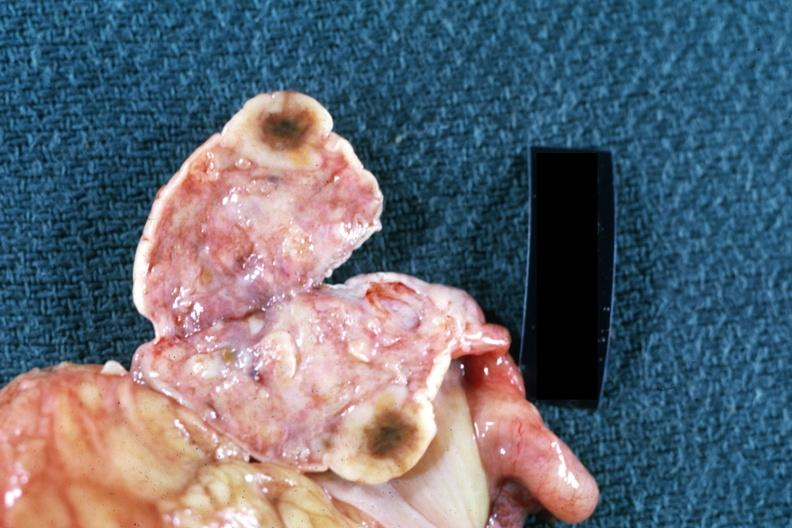s ovary present?
Answer the question using a single word or phrase. Yes 